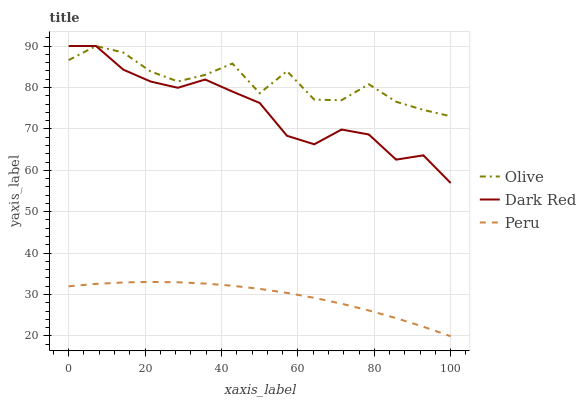Does Dark Red have the minimum area under the curve?
Answer yes or no. No. Does Dark Red have the maximum area under the curve?
Answer yes or no. No. Is Dark Red the smoothest?
Answer yes or no. No. Is Dark Red the roughest?
Answer yes or no. No. Does Dark Red have the lowest value?
Answer yes or no. No. Does Peru have the highest value?
Answer yes or no. No. Is Peru less than Olive?
Answer yes or no. Yes. Is Dark Red greater than Peru?
Answer yes or no. Yes. Does Peru intersect Olive?
Answer yes or no. No. 